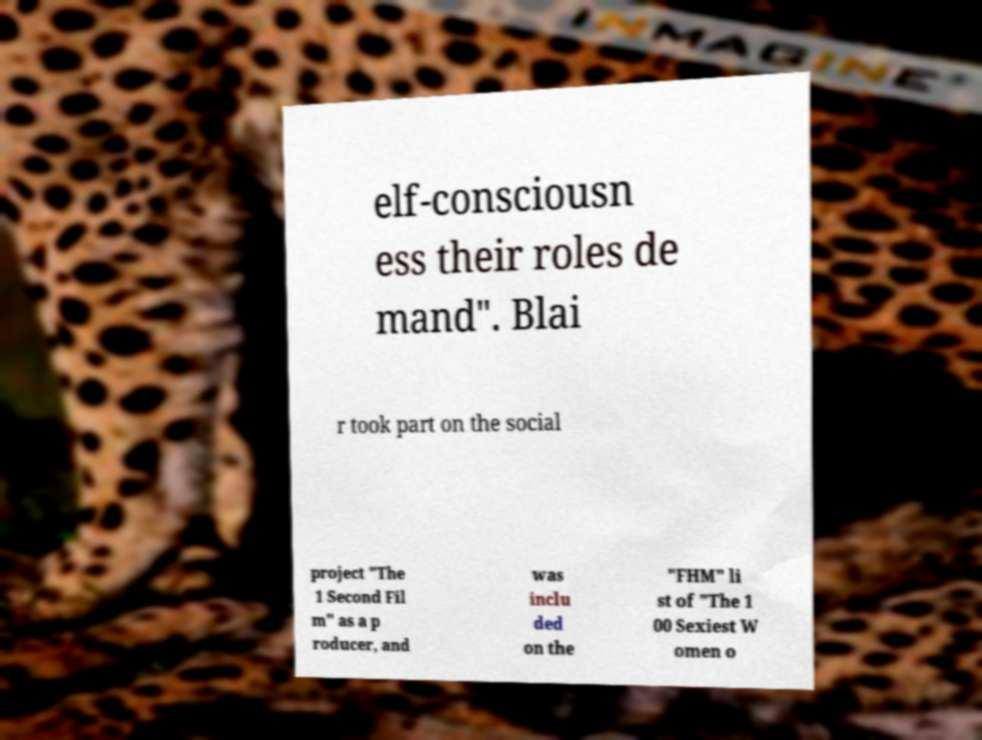Could you extract and type out the text from this image? elf-consciousn ess their roles de mand". Blai r took part on the social project "The 1 Second Fil m" as a p roducer, and was inclu ded on the "FHM" li st of "The 1 00 Sexiest W omen o 